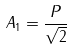<formula> <loc_0><loc_0><loc_500><loc_500>A _ { 1 } = \frac { P } { \sqrt { 2 } }</formula> 